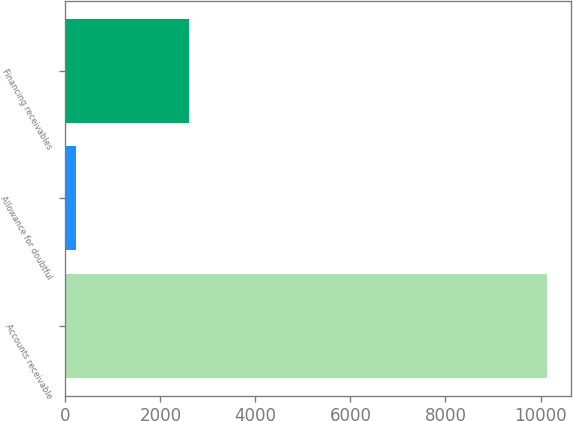Convert chart. <chart><loc_0><loc_0><loc_500><loc_500><bar_chart><fcel>Accounts receivable<fcel>Allowance for doubtful<fcel>Financing receivables<nl><fcel>10130<fcel>227<fcel>2608<nl></chart> 